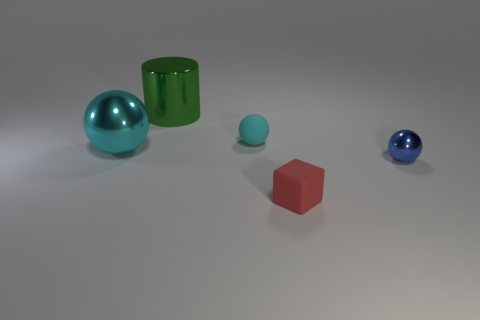Do the red rubber cube and the blue metallic thing have the same size?
Make the answer very short. Yes. Are there any blocks that are on the left side of the small ball that is to the left of the thing to the right of the rubber block?
Your answer should be compact. No. There is a blue object that is the same shape as the small cyan object; what material is it?
Give a very brief answer. Metal. There is a metal ball that is left of the blue metallic sphere; what color is it?
Keep it short and to the point. Cyan. There is a metal cylinder; is its size the same as the matte thing that is behind the small red rubber block?
Ensure brevity in your answer.  No. There is a shiny thing that is to the left of the large metallic object that is behind the shiny ball that is on the left side of the tiny blue shiny thing; what is its color?
Give a very brief answer. Cyan. Are the small thing on the left side of the small red cube and the cylinder made of the same material?
Keep it short and to the point. No. There is a blue thing that is the same size as the block; what is it made of?
Make the answer very short. Metal. Do the cyan object that is to the left of the green object and the matte object in front of the blue shiny thing have the same shape?
Keep it short and to the point. No. What is the shape of the metallic object that is the same size as the cube?
Ensure brevity in your answer.  Sphere. 